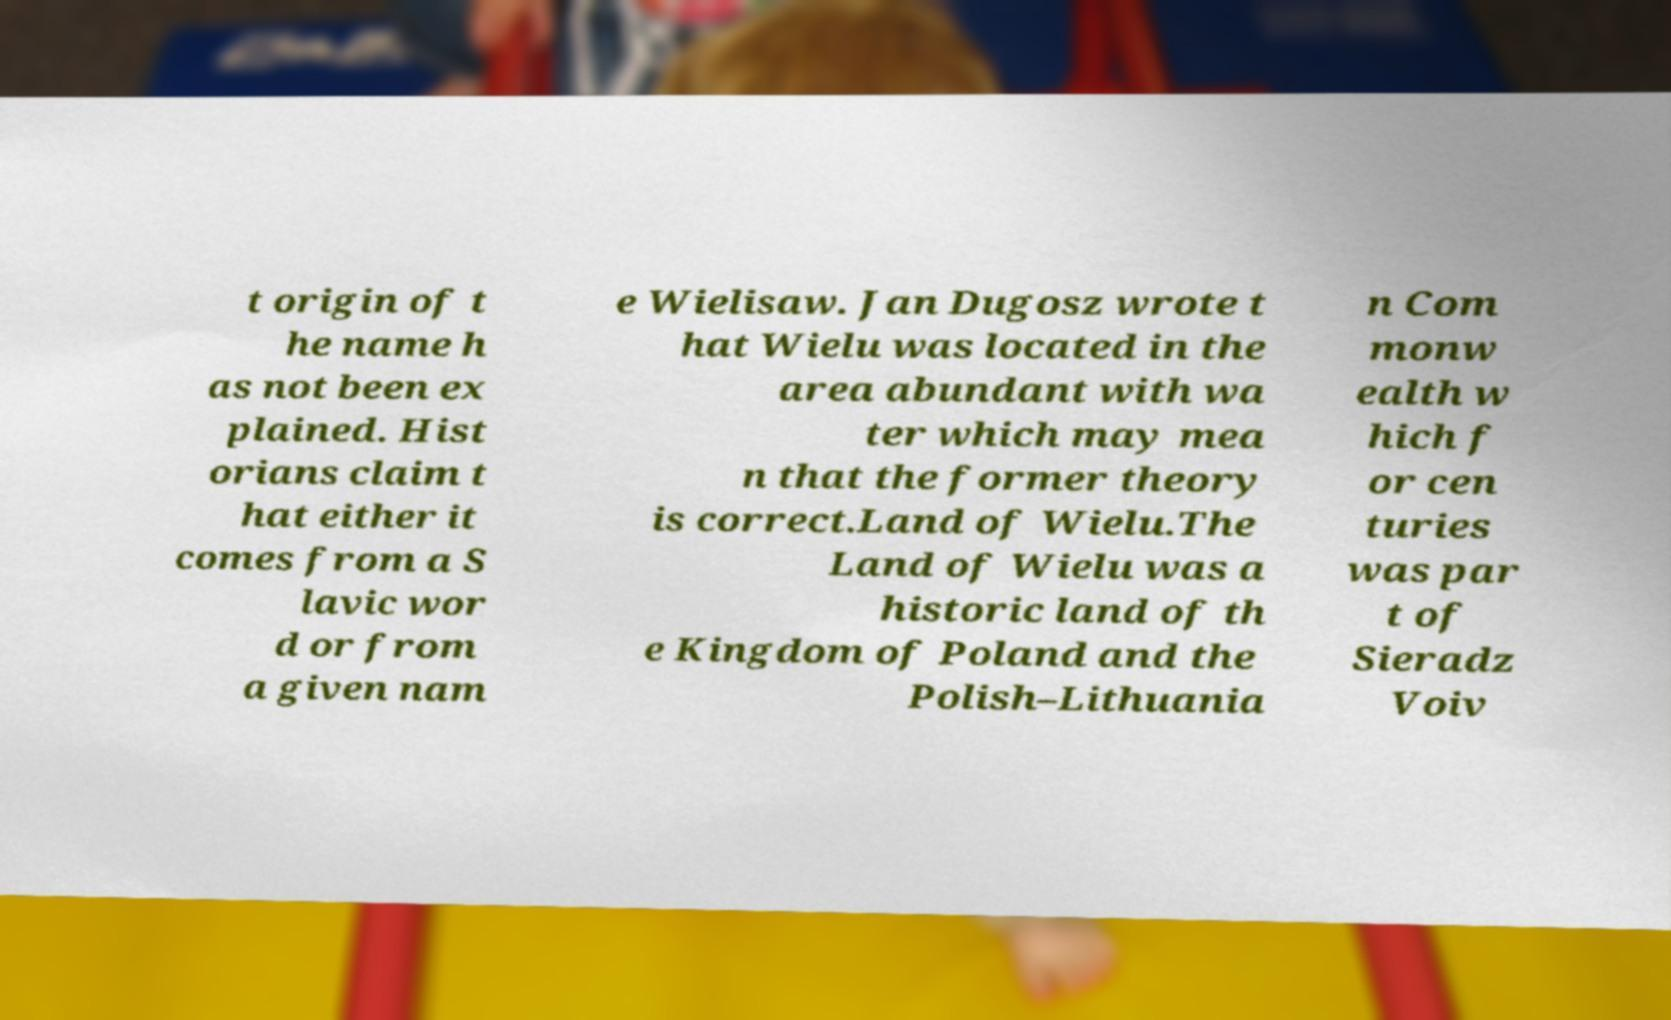Please identify and transcribe the text found in this image. t origin of t he name h as not been ex plained. Hist orians claim t hat either it comes from a S lavic wor d or from a given nam e Wielisaw. Jan Dugosz wrote t hat Wielu was located in the area abundant with wa ter which may mea n that the former theory is correct.Land of Wielu.The Land of Wielu was a historic land of th e Kingdom of Poland and the Polish–Lithuania n Com monw ealth w hich f or cen turies was par t of Sieradz Voiv 